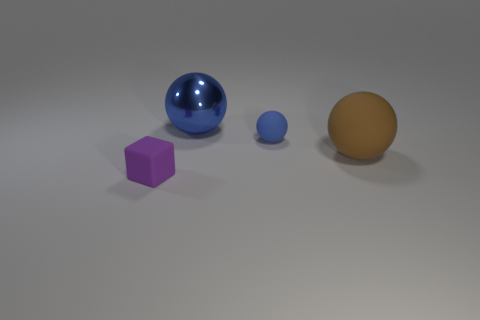Is the number of large things in front of the shiny thing the same as the number of blue spheres? no 